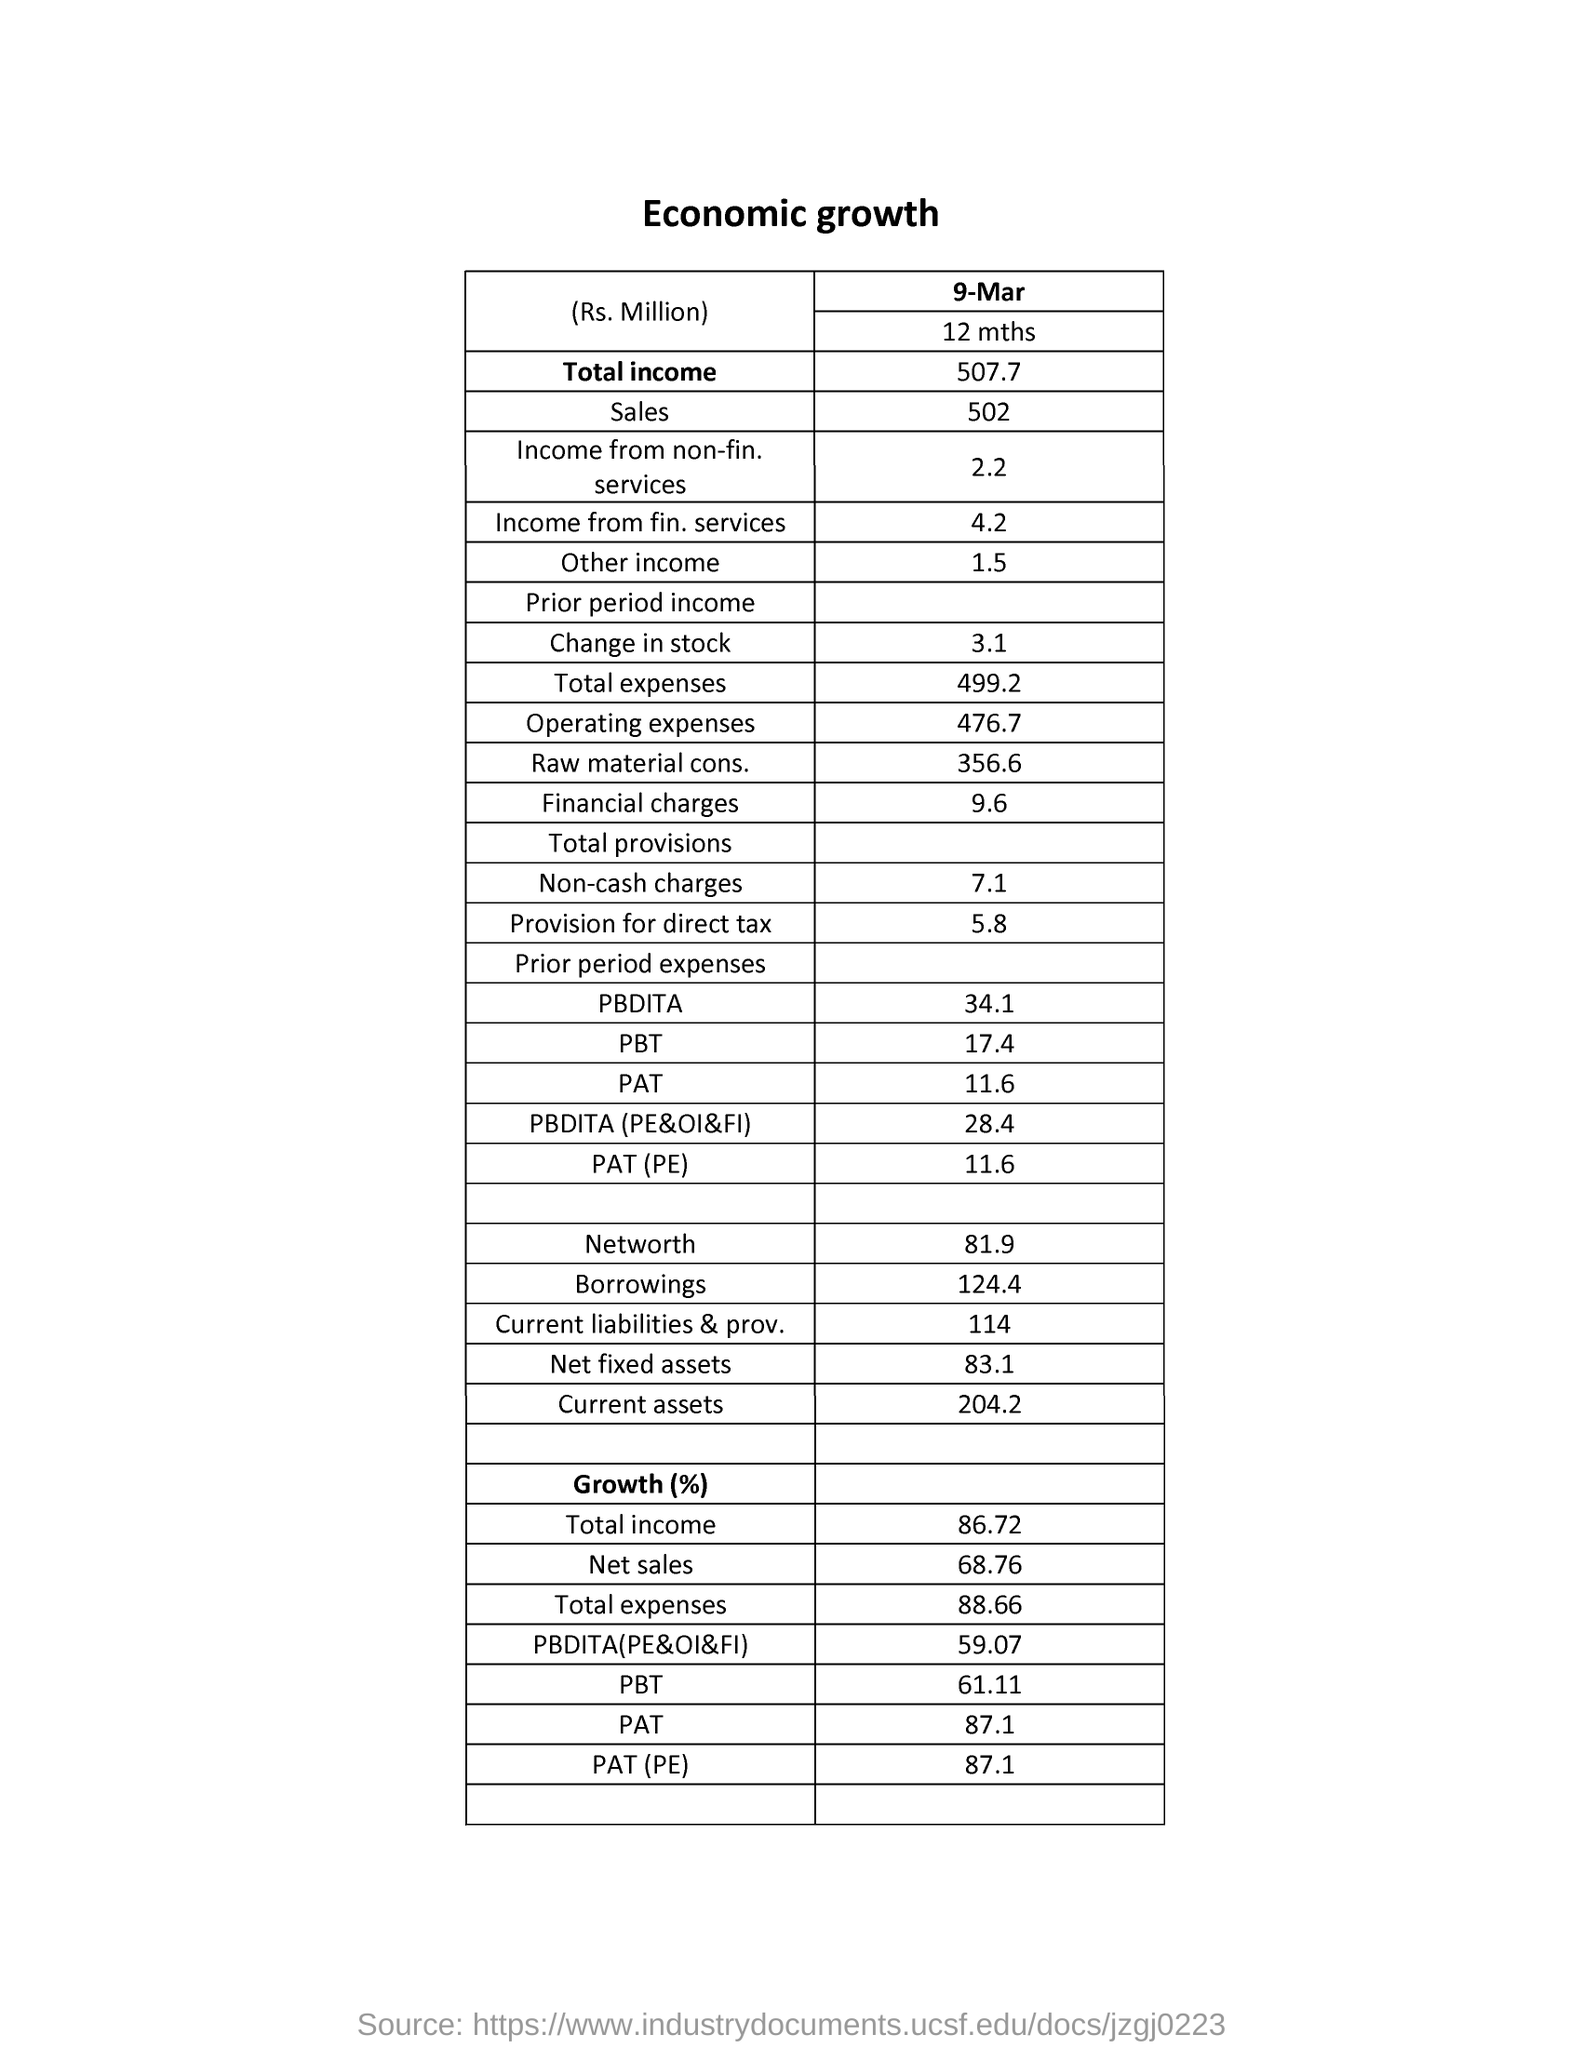List a handful of essential elements in this visual. The date specified in the document is 9 March. The non-cash charges for the period are estimated to be approximately 7 million. The growth percentage for PAT is 87, as of the end of the first quarter. The sales amount is approximately 502 million in millions. The net worth amount is approximately 81 million in millions. 